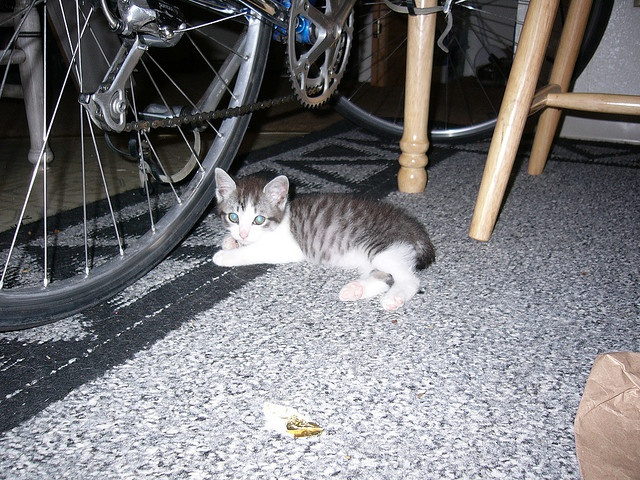Describe the objects in this image and their specific colors. I can see bicycle in black, gray, and darkgray tones, chair in black, gray, and tan tones, and cat in black, white, gray, and darkgray tones in this image. 